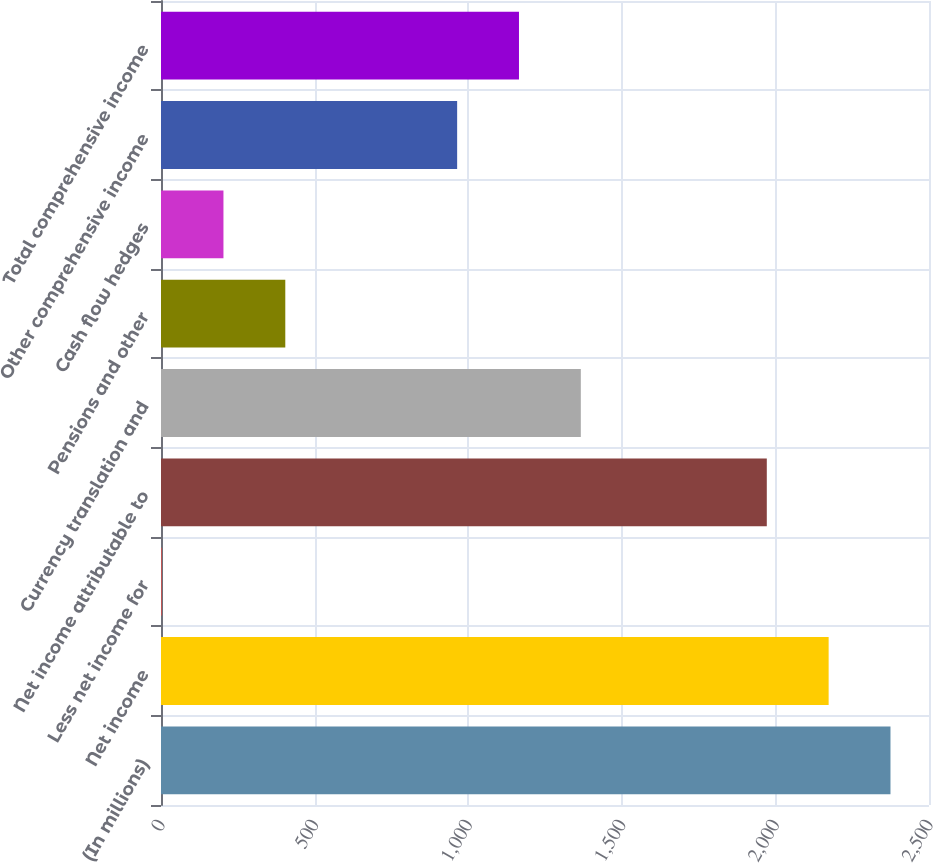Convert chart. <chart><loc_0><loc_0><loc_500><loc_500><bar_chart><fcel>(In millions)<fcel>Net income<fcel>Less net income for<fcel>Net income attributable to<fcel>Currency translation and<fcel>Pensions and other<fcel>Cash flow hedges<fcel>Other comprehensive income<fcel>Total comprehensive income<nl><fcel>2374.6<fcel>2173.3<fcel>2<fcel>1972<fcel>1366.6<fcel>404.6<fcel>203.3<fcel>964<fcel>1165.3<nl></chart> 